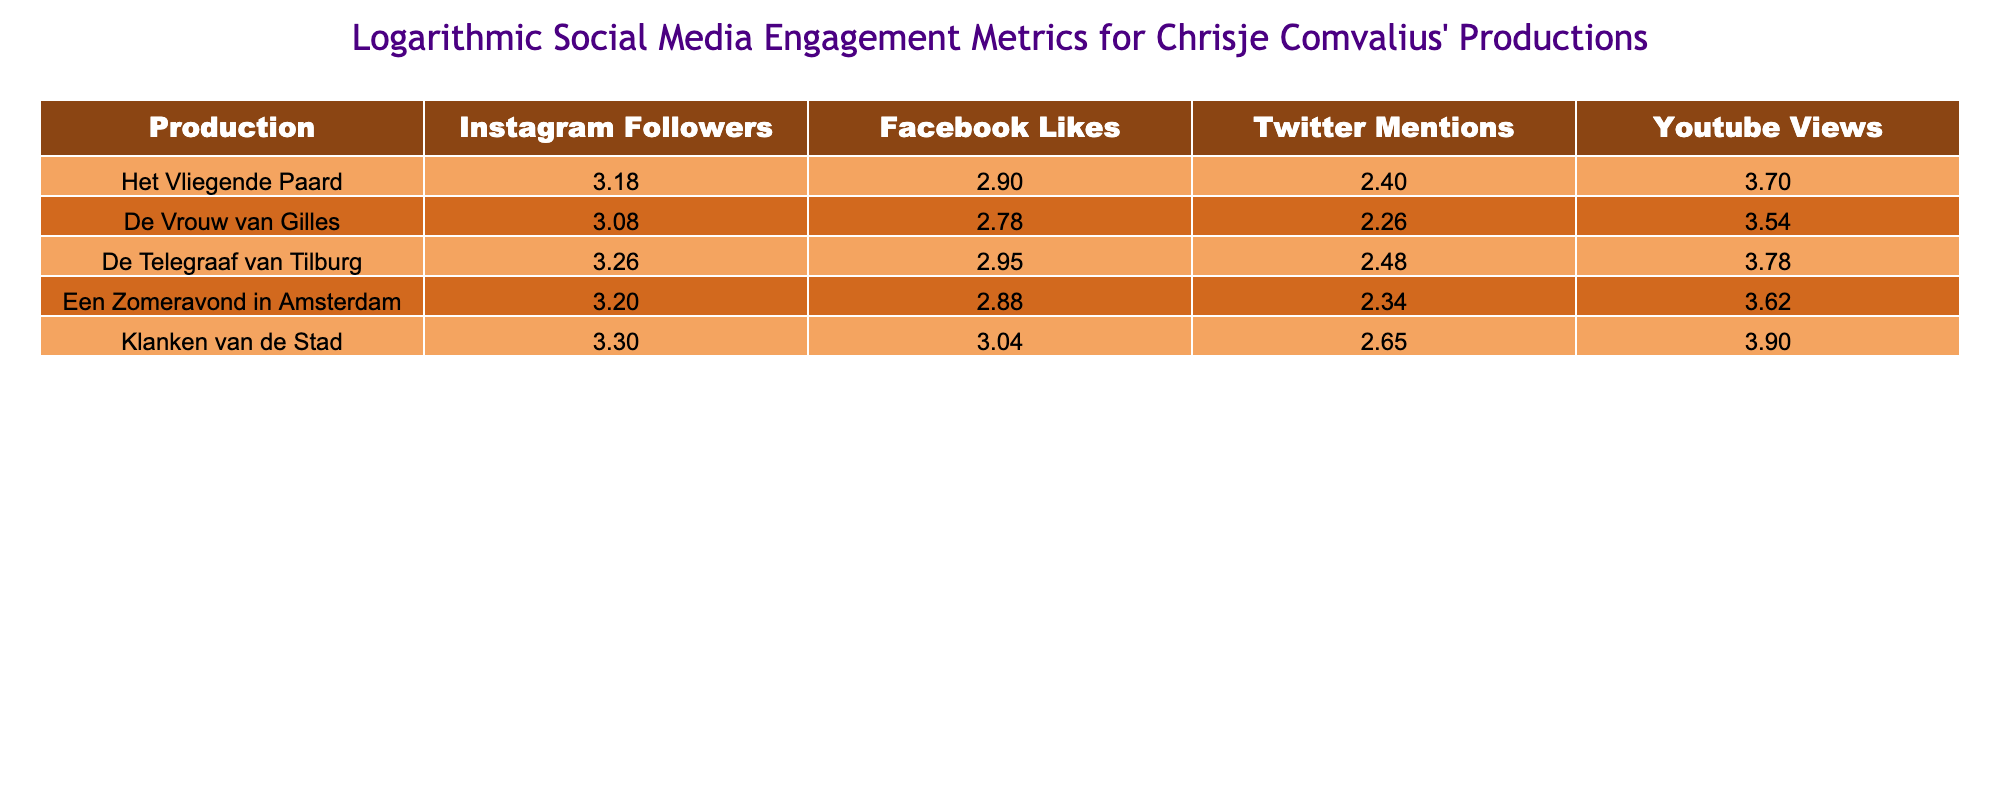What is the number of Instagram followers for "Klanken van de Stad"? The table shows the row for "Klanken van de Stad" with a value of 2000 in the Instagram Followers column.
Answer: 2000 Which production has the highest number of YouTube views? "Klanken van de Stad" has the highest number of YouTube views listed as 8000, which is more than the views of any other production.
Answer: "Klanken van de Stad" What is the sum of Facebook Likes for all the productions? The Facebook Likes are 800, 600, 900, 750, and 1100 for the five productions. Adding these gives 800 + 600 + 900 + 750 + 1100 = 4140.
Answer: 4140 How many more Twitter Mentions does "Het Vliegende Paard" have compared to "De Vrouw van Gilles"? "Het Vliegende Paard" has 250 Twitter Mentions, while "De Vrouw van Gilles" has 180. Subtracting gives 250 - 180 = 70.
Answer: 70 Is the average number of Instagram followers for the productions greater than 1500? The total Instagram followers across all productions is 1500 + 1200 + 1800 + 1600 + 2000 = 10100. Dividing this by 5 gives an average of 2020, which is greater than 1500.
Answer: Yes Which production has the lowest number of Twitter Mentions? "De Vrouw van Gilles" has 180 mentions, which is the lowest compared to the others listed in the table.
Answer: "De Vrouw van Gilles" What is the median number of Facebook Likes for all productions? Arranging the Facebook Likes in order gives 600, 750, 800, 900, and 1100. The median value, which is the middle number in this sorted list, is 800.
Answer: 800 How many productions have more than 700 Facebook Likes? The productions with Facebook Likes above 700 are "Het Vliegende Paard" (800), "Klanken van de Stad" (1100), "De Telegraaf van Tilburg" (900), and "Een Zomeravond in Amsterdam" (750), totaling four productions.
Answer: 4 